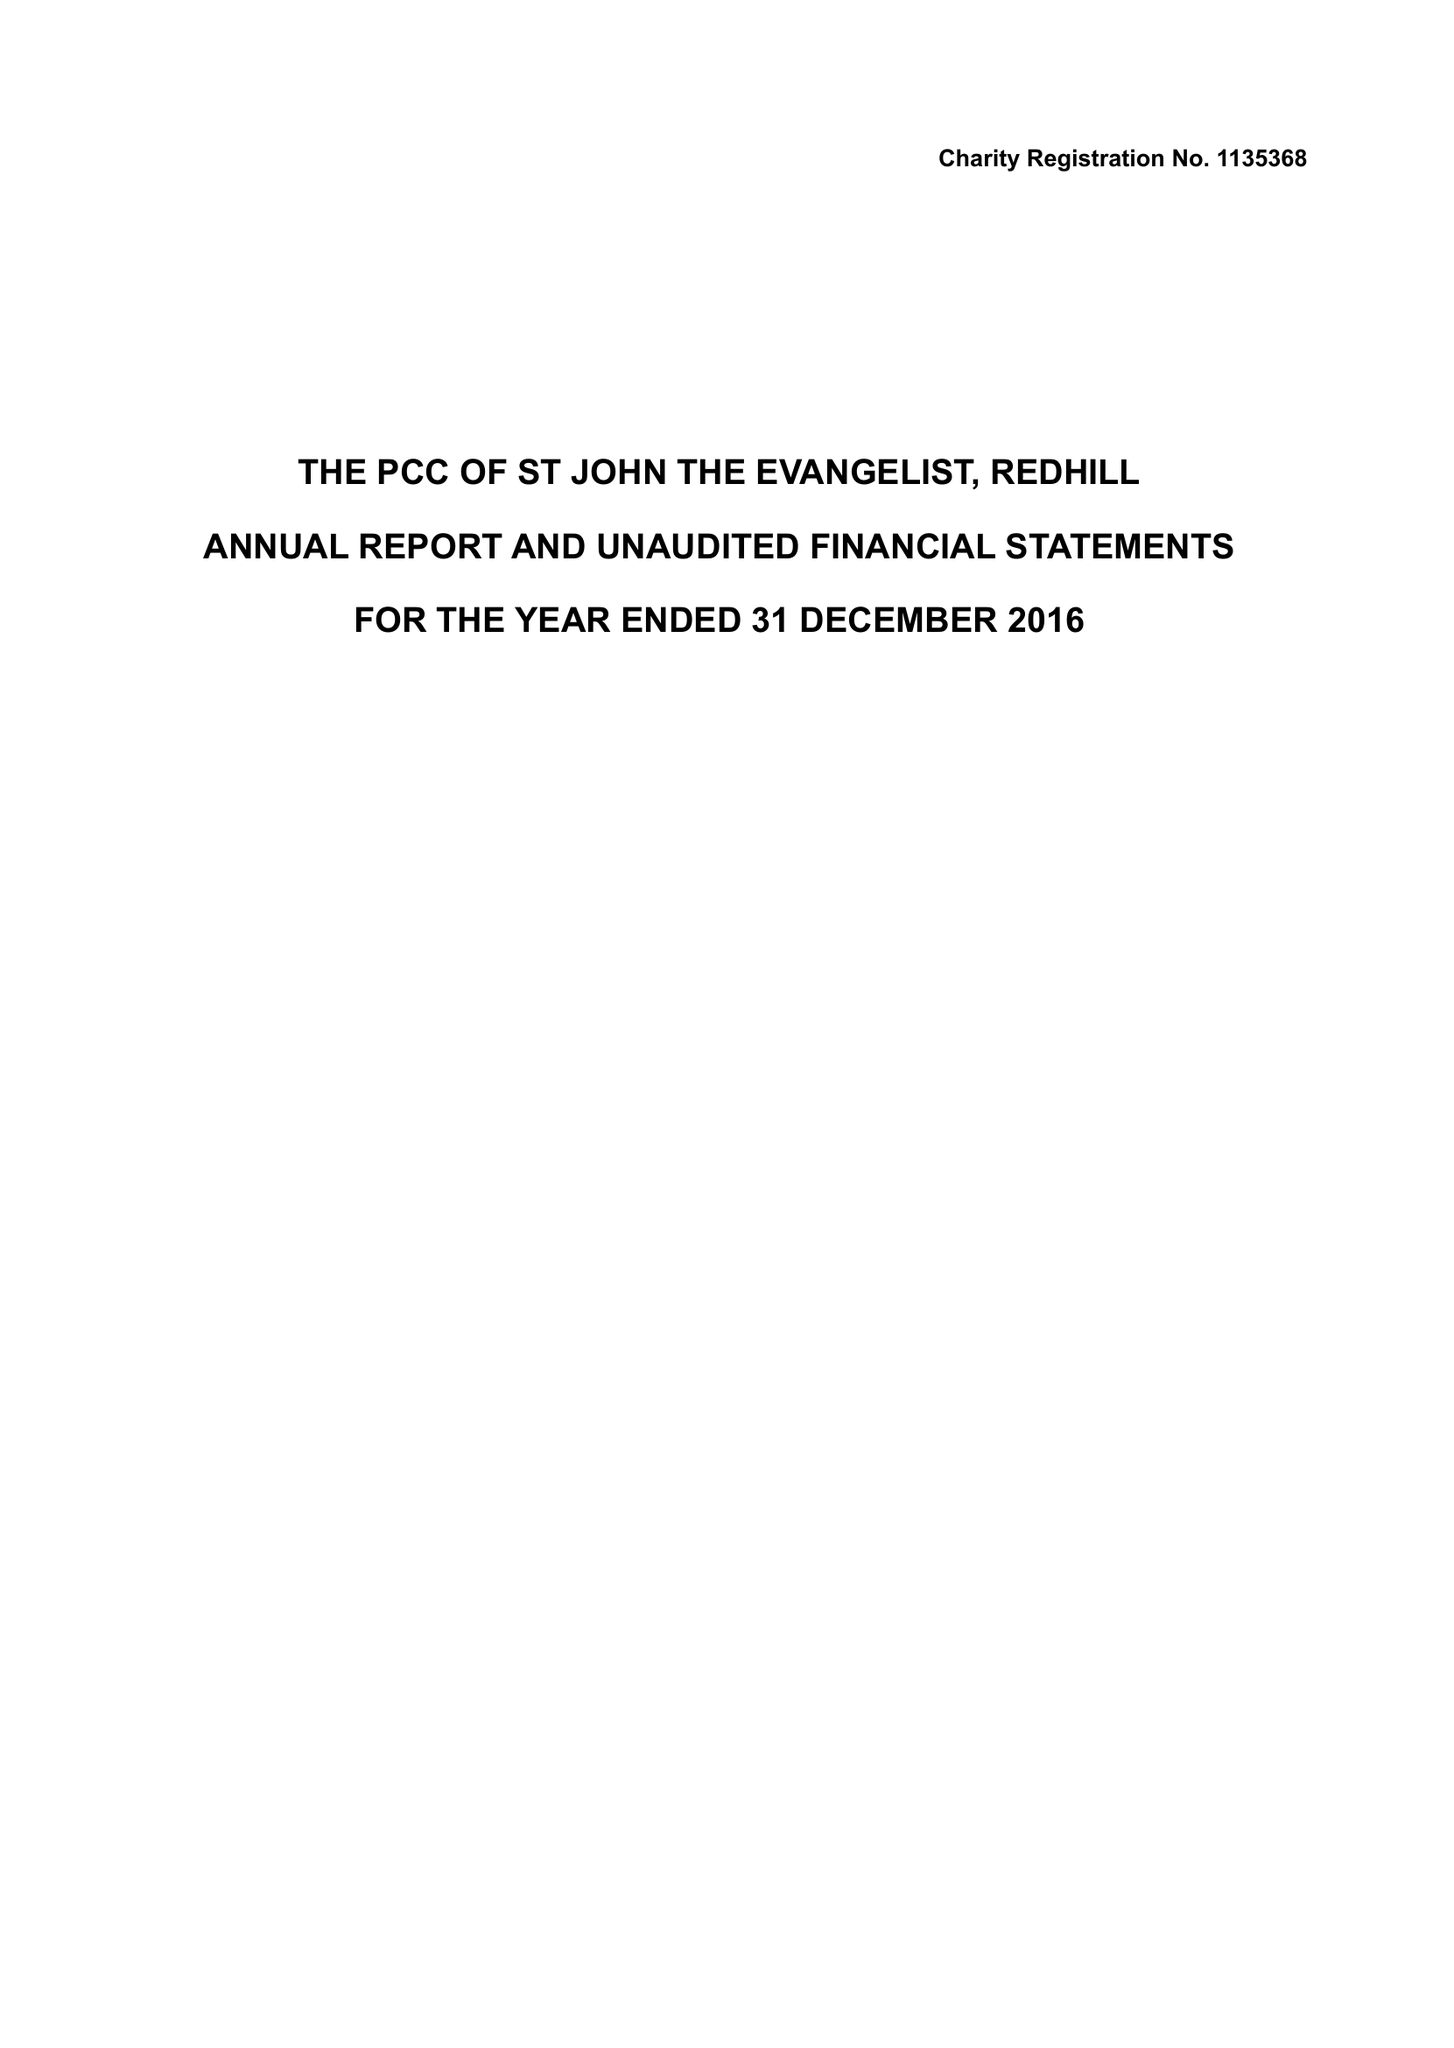What is the value for the address__street_line?
Answer the question using a single word or phrase. CHURCH ROAD 